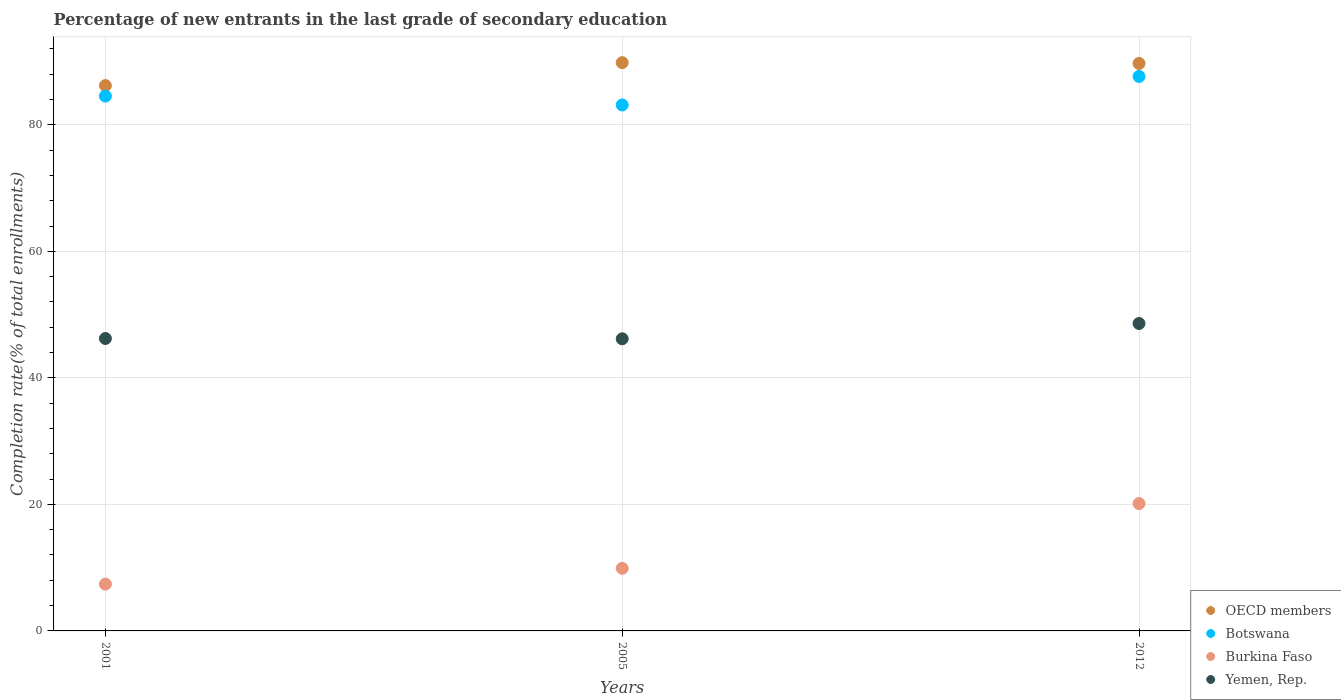How many different coloured dotlines are there?
Offer a very short reply. 4. What is the percentage of new entrants in Botswana in 2005?
Provide a short and direct response. 83.13. Across all years, what is the maximum percentage of new entrants in Botswana?
Your answer should be very brief. 87.64. Across all years, what is the minimum percentage of new entrants in Yemen, Rep.?
Provide a succinct answer. 46.17. What is the total percentage of new entrants in OECD members in the graph?
Provide a short and direct response. 265.71. What is the difference between the percentage of new entrants in OECD members in 2001 and that in 2005?
Your answer should be very brief. -3.63. What is the difference between the percentage of new entrants in Botswana in 2005 and the percentage of new entrants in Burkina Faso in 2012?
Provide a short and direct response. 63. What is the average percentage of new entrants in Burkina Faso per year?
Offer a very short reply. 12.47. In the year 2001, what is the difference between the percentage of new entrants in Botswana and percentage of new entrants in Burkina Faso?
Ensure brevity in your answer.  77.13. What is the ratio of the percentage of new entrants in OECD members in 2001 to that in 2012?
Provide a succinct answer. 0.96. Is the difference between the percentage of new entrants in Botswana in 2005 and 2012 greater than the difference between the percentage of new entrants in Burkina Faso in 2005 and 2012?
Your response must be concise. Yes. What is the difference between the highest and the second highest percentage of new entrants in Burkina Faso?
Your answer should be compact. 10.24. What is the difference between the highest and the lowest percentage of new entrants in Yemen, Rep.?
Offer a terse response. 2.42. In how many years, is the percentage of new entrants in Burkina Faso greater than the average percentage of new entrants in Burkina Faso taken over all years?
Your answer should be very brief. 1. Is it the case that in every year, the sum of the percentage of new entrants in Burkina Faso and percentage of new entrants in Botswana  is greater than the sum of percentage of new entrants in OECD members and percentage of new entrants in Yemen, Rep.?
Your answer should be very brief. Yes. Does the percentage of new entrants in Yemen, Rep. monotonically increase over the years?
Keep it short and to the point. No. Is the percentage of new entrants in Yemen, Rep. strictly greater than the percentage of new entrants in OECD members over the years?
Offer a very short reply. No. How many dotlines are there?
Your response must be concise. 4. What is the difference between two consecutive major ticks on the Y-axis?
Offer a very short reply. 20. Are the values on the major ticks of Y-axis written in scientific E-notation?
Your answer should be very brief. No. Does the graph contain any zero values?
Provide a succinct answer. No. Does the graph contain grids?
Your answer should be compact. Yes. Where does the legend appear in the graph?
Your response must be concise. Bottom right. How many legend labels are there?
Give a very brief answer. 4. What is the title of the graph?
Your answer should be very brief. Percentage of new entrants in the last grade of secondary education. Does "Haiti" appear as one of the legend labels in the graph?
Your answer should be compact. No. What is the label or title of the X-axis?
Provide a short and direct response. Years. What is the label or title of the Y-axis?
Keep it short and to the point. Completion rate(% of total enrollments). What is the Completion rate(% of total enrollments) of OECD members in 2001?
Your answer should be very brief. 86.19. What is the Completion rate(% of total enrollments) of Botswana in 2001?
Give a very brief answer. 84.53. What is the Completion rate(% of total enrollments) of Burkina Faso in 2001?
Your answer should be compact. 7.4. What is the Completion rate(% of total enrollments) in Yemen, Rep. in 2001?
Ensure brevity in your answer.  46.22. What is the Completion rate(% of total enrollments) of OECD members in 2005?
Offer a terse response. 89.82. What is the Completion rate(% of total enrollments) in Botswana in 2005?
Provide a succinct answer. 83.13. What is the Completion rate(% of total enrollments) of Burkina Faso in 2005?
Make the answer very short. 9.89. What is the Completion rate(% of total enrollments) of Yemen, Rep. in 2005?
Your answer should be compact. 46.17. What is the Completion rate(% of total enrollments) of OECD members in 2012?
Provide a succinct answer. 89.69. What is the Completion rate(% of total enrollments) in Botswana in 2012?
Offer a very short reply. 87.64. What is the Completion rate(% of total enrollments) of Burkina Faso in 2012?
Provide a succinct answer. 20.13. What is the Completion rate(% of total enrollments) in Yemen, Rep. in 2012?
Offer a terse response. 48.59. Across all years, what is the maximum Completion rate(% of total enrollments) in OECD members?
Offer a terse response. 89.82. Across all years, what is the maximum Completion rate(% of total enrollments) in Botswana?
Offer a very short reply. 87.64. Across all years, what is the maximum Completion rate(% of total enrollments) in Burkina Faso?
Provide a short and direct response. 20.13. Across all years, what is the maximum Completion rate(% of total enrollments) of Yemen, Rep.?
Make the answer very short. 48.59. Across all years, what is the minimum Completion rate(% of total enrollments) of OECD members?
Provide a short and direct response. 86.19. Across all years, what is the minimum Completion rate(% of total enrollments) of Botswana?
Provide a succinct answer. 83.13. Across all years, what is the minimum Completion rate(% of total enrollments) of Burkina Faso?
Keep it short and to the point. 7.4. Across all years, what is the minimum Completion rate(% of total enrollments) in Yemen, Rep.?
Your answer should be very brief. 46.17. What is the total Completion rate(% of total enrollments) of OECD members in the graph?
Give a very brief answer. 265.71. What is the total Completion rate(% of total enrollments) of Botswana in the graph?
Keep it short and to the point. 255.3. What is the total Completion rate(% of total enrollments) in Burkina Faso in the graph?
Offer a terse response. 37.42. What is the total Completion rate(% of total enrollments) of Yemen, Rep. in the graph?
Make the answer very short. 140.98. What is the difference between the Completion rate(% of total enrollments) in OECD members in 2001 and that in 2005?
Give a very brief answer. -3.62. What is the difference between the Completion rate(% of total enrollments) of Botswana in 2001 and that in 2005?
Provide a short and direct response. 1.4. What is the difference between the Completion rate(% of total enrollments) of Burkina Faso in 2001 and that in 2005?
Give a very brief answer. -2.49. What is the difference between the Completion rate(% of total enrollments) of Yemen, Rep. in 2001 and that in 2005?
Offer a very short reply. 0.05. What is the difference between the Completion rate(% of total enrollments) of OECD members in 2001 and that in 2012?
Your answer should be very brief. -3.5. What is the difference between the Completion rate(% of total enrollments) of Botswana in 2001 and that in 2012?
Provide a short and direct response. -3.11. What is the difference between the Completion rate(% of total enrollments) of Burkina Faso in 2001 and that in 2012?
Give a very brief answer. -12.73. What is the difference between the Completion rate(% of total enrollments) in Yemen, Rep. in 2001 and that in 2012?
Your answer should be compact. -2.37. What is the difference between the Completion rate(% of total enrollments) of OECD members in 2005 and that in 2012?
Give a very brief answer. 0.13. What is the difference between the Completion rate(% of total enrollments) of Botswana in 2005 and that in 2012?
Provide a succinct answer. -4.51. What is the difference between the Completion rate(% of total enrollments) in Burkina Faso in 2005 and that in 2012?
Provide a short and direct response. -10.24. What is the difference between the Completion rate(% of total enrollments) of Yemen, Rep. in 2005 and that in 2012?
Give a very brief answer. -2.42. What is the difference between the Completion rate(% of total enrollments) in OECD members in 2001 and the Completion rate(% of total enrollments) in Botswana in 2005?
Offer a very short reply. 3.06. What is the difference between the Completion rate(% of total enrollments) in OECD members in 2001 and the Completion rate(% of total enrollments) in Burkina Faso in 2005?
Give a very brief answer. 76.3. What is the difference between the Completion rate(% of total enrollments) of OECD members in 2001 and the Completion rate(% of total enrollments) of Yemen, Rep. in 2005?
Offer a very short reply. 40.02. What is the difference between the Completion rate(% of total enrollments) in Botswana in 2001 and the Completion rate(% of total enrollments) in Burkina Faso in 2005?
Keep it short and to the point. 74.64. What is the difference between the Completion rate(% of total enrollments) of Botswana in 2001 and the Completion rate(% of total enrollments) of Yemen, Rep. in 2005?
Your answer should be compact. 38.36. What is the difference between the Completion rate(% of total enrollments) in Burkina Faso in 2001 and the Completion rate(% of total enrollments) in Yemen, Rep. in 2005?
Your answer should be very brief. -38.77. What is the difference between the Completion rate(% of total enrollments) of OECD members in 2001 and the Completion rate(% of total enrollments) of Botswana in 2012?
Make the answer very short. -1.44. What is the difference between the Completion rate(% of total enrollments) in OECD members in 2001 and the Completion rate(% of total enrollments) in Burkina Faso in 2012?
Offer a very short reply. 66.07. What is the difference between the Completion rate(% of total enrollments) of OECD members in 2001 and the Completion rate(% of total enrollments) of Yemen, Rep. in 2012?
Give a very brief answer. 37.61. What is the difference between the Completion rate(% of total enrollments) in Botswana in 2001 and the Completion rate(% of total enrollments) in Burkina Faso in 2012?
Make the answer very short. 64.4. What is the difference between the Completion rate(% of total enrollments) in Botswana in 2001 and the Completion rate(% of total enrollments) in Yemen, Rep. in 2012?
Provide a short and direct response. 35.94. What is the difference between the Completion rate(% of total enrollments) of Burkina Faso in 2001 and the Completion rate(% of total enrollments) of Yemen, Rep. in 2012?
Make the answer very short. -41.19. What is the difference between the Completion rate(% of total enrollments) of OECD members in 2005 and the Completion rate(% of total enrollments) of Botswana in 2012?
Offer a terse response. 2.18. What is the difference between the Completion rate(% of total enrollments) of OECD members in 2005 and the Completion rate(% of total enrollments) of Burkina Faso in 2012?
Your answer should be very brief. 69.69. What is the difference between the Completion rate(% of total enrollments) in OECD members in 2005 and the Completion rate(% of total enrollments) in Yemen, Rep. in 2012?
Ensure brevity in your answer.  41.23. What is the difference between the Completion rate(% of total enrollments) of Botswana in 2005 and the Completion rate(% of total enrollments) of Burkina Faso in 2012?
Ensure brevity in your answer.  63. What is the difference between the Completion rate(% of total enrollments) of Botswana in 2005 and the Completion rate(% of total enrollments) of Yemen, Rep. in 2012?
Give a very brief answer. 34.54. What is the difference between the Completion rate(% of total enrollments) in Burkina Faso in 2005 and the Completion rate(% of total enrollments) in Yemen, Rep. in 2012?
Your answer should be very brief. -38.7. What is the average Completion rate(% of total enrollments) of OECD members per year?
Provide a short and direct response. 88.57. What is the average Completion rate(% of total enrollments) of Botswana per year?
Give a very brief answer. 85.1. What is the average Completion rate(% of total enrollments) of Burkina Faso per year?
Keep it short and to the point. 12.47. What is the average Completion rate(% of total enrollments) in Yemen, Rep. per year?
Offer a very short reply. 46.99. In the year 2001, what is the difference between the Completion rate(% of total enrollments) of OECD members and Completion rate(% of total enrollments) of Botswana?
Offer a terse response. 1.66. In the year 2001, what is the difference between the Completion rate(% of total enrollments) in OECD members and Completion rate(% of total enrollments) in Burkina Faso?
Offer a terse response. 78.79. In the year 2001, what is the difference between the Completion rate(% of total enrollments) in OECD members and Completion rate(% of total enrollments) in Yemen, Rep.?
Your response must be concise. 39.97. In the year 2001, what is the difference between the Completion rate(% of total enrollments) in Botswana and Completion rate(% of total enrollments) in Burkina Faso?
Provide a short and direct response. 77.13. In the year 2001, what is the difference between the Completion rate(% of total enrollments) in Botswana and Completion rate(% of total enrollments) in Yemen, Rep.?
Your answer should be compact. 38.31. In the year 2001, what is the difference between the Completion rate(% of total enrollments) in Burkina Faso and Completion rate(% of total enrollments) in Yemen, Rep.?
Your answer should be very brief. -38.82. In the year 2005, what is the difference between the Completion rate(% of total enrollments) of OECD members and Completion rate(% of total enrollments) of Botswana?
Your answer should be compact. 6.69. In the year 2005, what is the difference between the Completion rate(% of total enrollments) of OECD members and Completion rate(% of total enrollments) of Burkina Faso?
Make the answer very short. 79.93. In the year 2005, what is the difference between the Completion rate(% of total enrollments) in OECD members and Completion rate(% of total enrollments) in Yemen, Rep.?
Provide a short and direct response. 43.65. In the year 2005, what is the difference between the Completion rate(% of total enrollments) of Botswana and Completion rate(% of total enrollments) of Burkina Faso?
Offer a terse response. 73.24. In the year 2005, what is the difference between the Completion rate(% of total enrollments) in Botswana and Completion rate(% of total enrollments) in Yemen, Rep.?
Offer a terse response. 36.96. In the year 2005, what is the difference between the Completion rate(% of total enrollments) of Burkina Faso and Completion rate(% of total enrollments) of Yemen, Rep.?
Ensure brevity in your answer.  -36.28. In the year 2012, what is the difference between the Completion rate(% of total enrollments) of OECD members and Completion rate(% of total enrollments) of Botswana?
Your answer should be very brief. 2.05. In the year 2012, what is the difference between the Completion rate(% of total enrollments) in OECD members and Completion rate(% of total enrollments) in Burkina Faso?
Offer a very short reply. 69.56. In the year 2012, what is the difference between the Completion rate(% of total enrollments) of OECD members and Completion rate(% of total enrollments) of Yemen, Rep.?
Provide a short and direct response. 41.1. In the year 2012, what is the difference between the Completion rate(% of total enrollments) in Botswana and Completion rate(% of total enrollments) in Burkina Faso?
Offer a terse response. 67.51. In the year 2012, what is the difference between the Completion rate(% of total enrollments) of Botswana and Completion rate(% of total enrollments) of Yemen, Rep.?
Offer a very short reply. 39.05. In the year 2012, what is the difference between the Completion rate(% of total enrollments) in Burkina Faso and Completion rate(% of total enrollments) in Yemen, Rep.?
Give a very brief answer. -28.46. What is the ratio of the Completion rate(% of total enrollments) of OECD members in 2001 to that in 2005?
Provide a succinct answer. 0.96. What is the ratio of the Completion rate(% of total enrollments) of Botswana in 2001 to that in 2005?
Provide a short and direct response. 1.02. What is the ratio of the Completion rate(% of total enrollments) of Burkina Faso in 2001 to that in 2005?
Offer a very short reply. 0.75. What is the ratio of the Completion rate(% of total enrollments) of Botswana in 2001 to that in 2012?
Your answer should be very brief. 0.96. What is the ratio of the Completion rate(% of total enrollments) in Burkina Faso in 2001 to that in 2012?
Your response must be concise. 0.37. What is the ratio of the Completion rate(% of total enrollments) in Yemen, Rep. in 2001 to that in 2012?
Keep it short and to the point. 0.95. What is the ratio of the Completion rate(% of total enrollments) in OECD members in 2005 to that in 2012?
Provide a succinct answer. 1. What is the ratio of the Completion rate(% of total enrollments) in Botswana in 2005 to that in 2012?
Keep it short and to the point. 0.95. What is the ratio of the Completion rate(% of total enrollments) in Burkina Faso in 2005 to that in 2012?
Your answer should be compact. 0.49. What is the ratio of the Completion rate(% of total enrollments) of Yemen, Rep. in 2005 to that in 2012?
Keep it short and to the point. 0.95. What is the difference between the highest and the second highest Completion rate(% of total enrollments) in OECD members?
Your answer should be very brief. 0.13. What is the difference between the highest and the second highest Completion rate(% of total enrollments) of Botswana?
Your response must be concise. 3.11. What is the difference between the highest and the second highest Completion rate(% of total enrollments) of Burkina Faso?
Offer a terse response. 10.24. What is the difference between the highest and the second highest Completion rate(% of total enrollments) of Yemen, Rep.?
Ensure brevity in your answer.  2.37. What is the difference between the highest and the lowest Completion rate(% of total enrollments) in OECD members?
Provide a short and direct response. 3.62. What is the difference between the highest and the lowest Completion rate(% of total enrollments) in Botswana?
Keep it short and to the point. 4.51. What is the difference between the highest and the lowest Completion rate(% of total enrollments) of Burkina Faso?
Your answer should be very brief. 12.73. What is the difference between the highest and the lowest Completion rate(% of total enrollments) in Yemen, Rep.?
Provide a succinct answer. 2.42. 